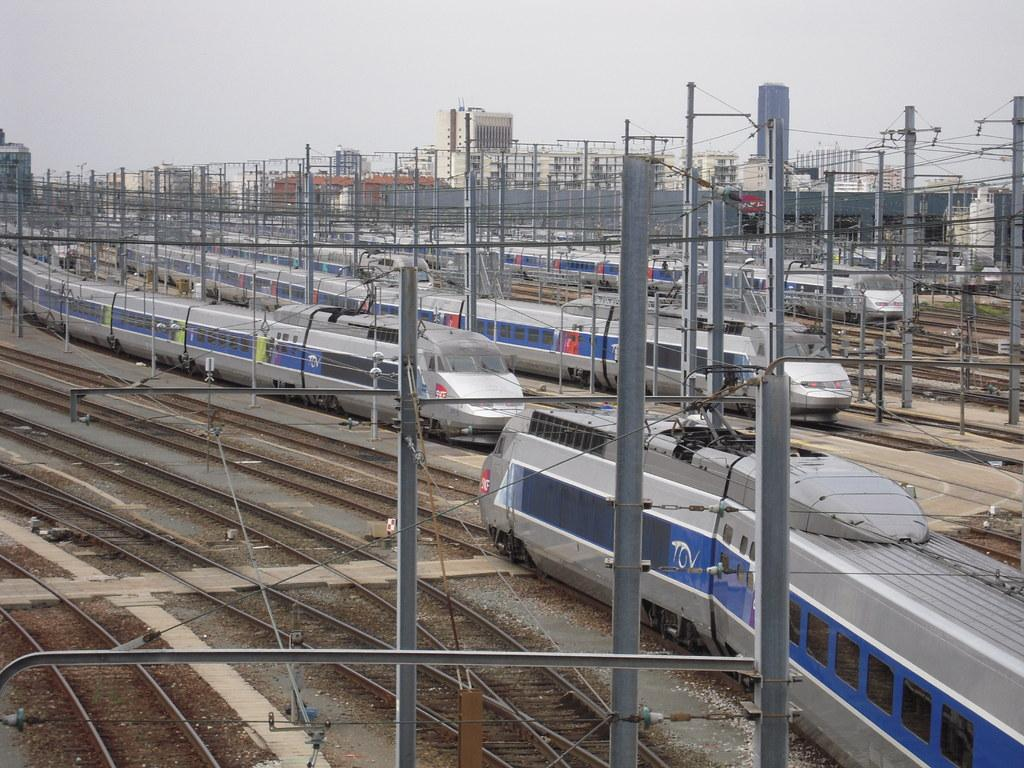What type of vehicles can be seen in the image? There are trains on railway tracks in the image. What else can be seen alongside the railway tracks? There are poles with wires in the image. What structures are visible in the image? There are buildings in the image. What can be seen in the background of the image? The sky is visible in the background of the image. What type of plate is being used to serve the food in the image? There is no plate or food present in the image; it features trains on railway tracks, poles with wires, buildings, and the sky. What type of roof can be seen on the train in the image? There are no visible roofs on the trains in the image, as the focus is on the trains themselves and not their individual components. 